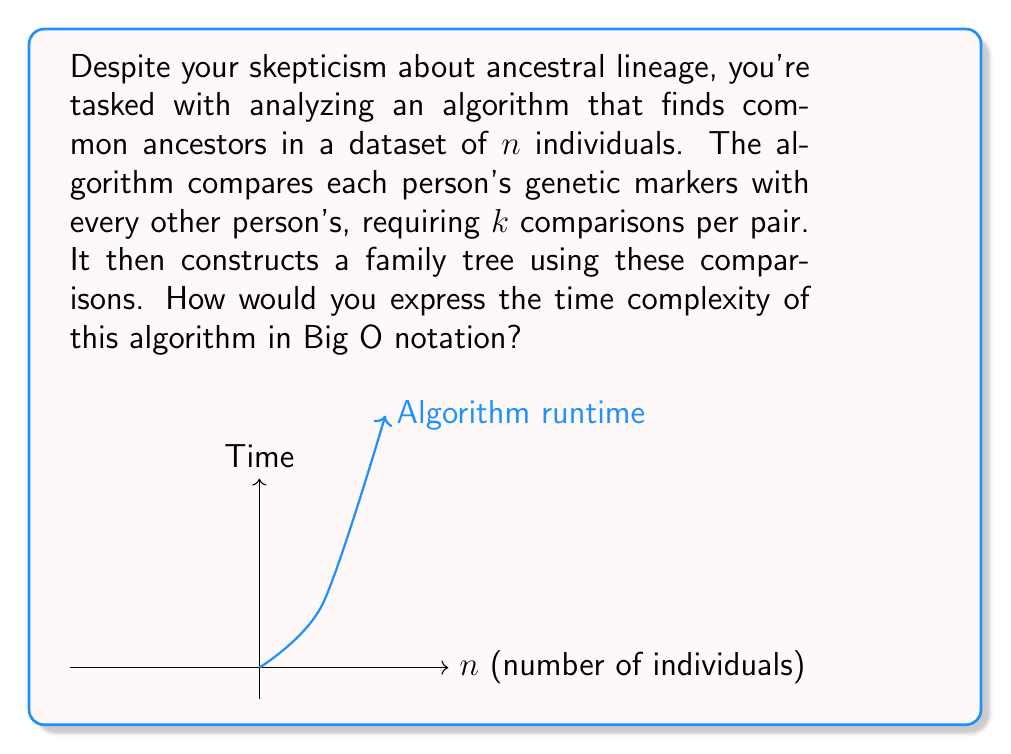Help me with this question. Let's break this down step-by-step:

1) First, we need to consider how many comparisons are made:
   - There are $n$ individuals in the dataset.
   - Each individual is compared with every other individual.
   - This forms $\frac{n(n-1)}{2}$ pairs to compare.

2) For each pair, $k$ comparisons are made:
   - Total number of comparisons = $k \cdot \frac{n(n-1)}{2}$

3) Simplifying this expression:
   $$k \cdot \frac{n(n-1)}{2} = \frac{kn^2 - kn}{2}$$

4) In Big O notation, we're concerned with the dominant term as $n$ grows large:
   - The $n^2$ term dominates as $n$ increases.
   - Constants ($k$ and $\frac{1}{2}$) are dropped in Big O notation.

5) After the comparisons, the algorithm constructs a family tree:
   - This step is typically $O(n)$ or $O(n \log n)$, which is dominated by the $O(n^2)$ comparisons.

6) Therefore, the overall time complexity is $O(n^2)$.

This quadratic time complexity explains why such algorithms can be very time-consuming for large datasets, regardless of one's personal views on ancestral importance.
Answer: $O(n^2)$ 